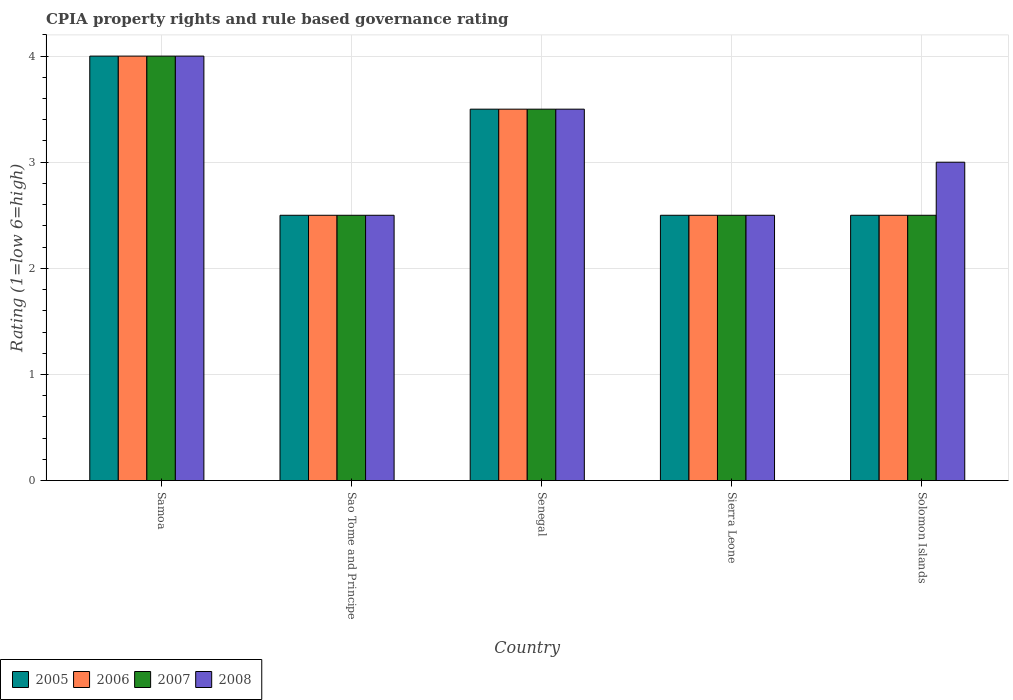How many different coloured bars are there?
Make the answer very short. 4. How many groups of bars are there?
Your answer should be compact. 5. Are the number of bars on each tick of the X-axis equal?
Make the answer very short. Yes. How many bars are there on the 2nd tick from the right?
Provide a succinct answer. 4. What is the label of the 1st group of bars from the left?
Provide a short and direct response. Samoa. What is the CPIA rating in 2005 in Solomon Islands?
Offer a very short reply. 2.5. Across all countries, what is the minimum CPIA rating in 2005?
Make the answer very short. 2.5. In which country was the CPIA rating in 2005 maximum?
Provide a short and direct response. Samoa. In which country was the CPIA rating in 2005 minimum?
Make the answer very short. Sao Tome and Principe. What is the total CPIA rating in 2006 in the graph?
Make the answer very short. 15. What is the difference between the CPIA rating in 2005 in Solomon Islands and the CPIA rating in 2007 in Senegal?
Provide a succinct answer. -1. What is the difference between the CPIA rating of/in 2006 and CPIA rating of/in 2005 in Solomon Islands?
Offer a terse response. 0. In how many countries, is the CPIA rating in 2007 greater than 3?
Offer a terse response. 2. Is the CPIA rating in 2008 in Samoa less than that in Senegal?
Make the answer very short. No. What is the difference between the highest and the second highest CPIA rating in 2006?
Give a very brief answer. -1. In how many countries, is the CPIA rating in 2006 greater than the average CPIA rating in 2006 taken over all countries?
Provide a succinct answer. 2. Is the sum of the CPIA rating in 2008 in Samoa and Sao Tome and Principe greater than the maximum CPIA rating in 2006 across all countries?
Your answer should be compact. Yes. What does the 3rd bar from the left in Sierra Leone represents?
Keep it short and to the point. 2007. Is it the case that in every country, the sum of the CPIA rating in 2005 and CPIA rating in 2008 is greater than the CPIA rating in 2006?
Provide a short and direct response. Yes. Are all the bars in the graph horizontal?
Your answer should be compact. No. Does the graph contain any zero values?
Make the answer very short. No. Does the graph contain grids?
Make the answer very short. Yes. What is the title of the graph?
Offer a terse response. CPIA property rights and rule based governance rating. Does "1985" appear as one of the legend labels in the graph?
Offer a very short reply. No. What is the Rating (1=low 6=high) of 2005 in Samoa?
Your answer should be compact. 4. What is the Rating (1=low 6=high) in 2006 in Samoa?
Keep it short and to the point. 4. What is the Rating (1=low 6=high) of 2007 in Samoa?
Provide a succinct answer. 4. What is the Rating (1=low 6=high) in 2008 in Samoa?
Make the answer very short. 4. What is the Rating (1=low 6=high) of 2006 in Sao Tome and Principe?
Offer a terse response. 2.5. What is the Rating (1=low 6=high) of 2005 in Senegal?
Offer a terse response. 3.5. What is the Rating (1=low 6=high) of 2008 in Senegal?
Provide a short and direct response. 3.5. What is the Rating (1=low 6=high) in 2005 in Sierra Leone?
Your response must be concise. 2.5. What is the Rating (1=low 6=high) of 2007 in Sierra Leone?
Offer a very short reply. 2.5. Across all countries, what is the maximum Rating (1=low 6=high) of 2005?
Offer a very short reply. 4. Across all countries, what is the maximum Rating (1=low 6=high) in 2006?
Your response must be concise. 4. Across all countries, what is the minimum Rating (1=low 6=high) of 2005?
Provide a short and direct response. 2.5. Across all countries, what is the minimum Rating (1=low 6=high) of 2006?
Provide a succinct answer. 2.5. Across all countries, what is the minimum Rating (1=low 6=high) in 2007?
Give a very brief answer. 2.5. Across all countries, what is the minimum Rating (1=low 6=high) of 2008?
Give a very brief answer. 2.5. What is the total Rating (1=low 6=high) in 2006 in the graph?
Ensure brevity in your answer.  15. What is the total Rating (1=low 6=high) of 2007 in the graph?
Make the answer very short. 15. What is the total Rating (1=low 6=high) in 2008 in the graph?
Ensure brevity in your answer.  15.5. What is the difference between the Rating (1=low 6=high) of 2006 in Samoa and that in Sao Tome and Principe?
Offer a terse response. 1.5. What is the difference between the Rating (1=low 6=high) in 2007 in Samoa and that in Sao Tome and Principe?
Ensure brevity in your answer.  1.5. What is the difference between the Rating (1=low 6=high) in 2005 in Samoa and that in Sierra Leone?
Provide a short and direct response. 1.5. What is the difference between the Rating (1=low 6=high) of 2006 in Samoa and that in Sierra Leone?
Provide a succinct answer. 1.5. What is the difference between the Rating (1=low 6=high) of 2007 in Samoa and that in Sierra Leone?
Keep it short and to the point. 1.5. What is the difference between the Rating (1=low 6=high) in 2008 in Samoa and that in Sierra Leone?
Offer a very short reply. 1.5. What is the difference between the Rating (1=low 6=high) in 2005 in Samoa and that in Solomon Islands?
Provide a succinct answer. 1.5. What is the difference between the Rating (1=low 6=high) in 2006 in Samoa and that in Solomon Islands?
Ensure brevity in your answer.  1.5. What is the difference between the Rating (1=low 6=high) of 2007 in Samoa and that in Solomon Islands?
Ensure brevity in your answer.  1.5. What is the difference between the Rating (1=low 6=high) of 2008 in Samoa and that in Solomon Islands?
Offer a terse response. 1. What is the difference between the Rating (1=low 6=high) of 2005 in Sao Tome and Principe and that in Senegal?
Give a very brief answer. -1. What is the difference between the Rating (1=low 6=high) of 2007 in Sao Tome and Principe and that in Senegal?
Your answer should be very brief. -1. What is the difference between the Rating (1=low 6=high) of 2008 in Sao Tome and Principe and that in Senegal?
Make the answer very short. -1. What is the difference between the Rating (1=low 6=high) of 2005 in Sao Tome and Principe and that in Sierra Leone?
Provide a short and direct response. 0. What is the difference between the Rating (1=low 6=high) of 2006 in Sao Tome and Principe and that in Sierra Leone?
Keep it short and to the point. 0. What is the difference between the Rating (1=low 6=high) of 2006 in Sao Tome and Principe and that in Solomon Islands?
Your answer should be very brief. 0. What is the difference between the Rating (1=low 6=high) of 2007 in Sao Tome and Principe and that in Solomon Islands?
Your response must be concise. 0. What is the difference between the Rating (1=low 6=high) of 2005 in Senegal and that in Solomon Islands?
Give a very brief answer. 1. What is the difference between the Rating (1=low 6=high) of 2007 in Senegal and that in Solomon Islands?
Your answer should be very brief. 1. What is the difference between the Rating (1=low 6=high) of 2005 in Sierra Leone and that in Solomon Islands?
Make the answer very short. 0. What is the difference between the Rating (1=low 6=high) of 2006 in Sierra Leone and that in Solomon Islands?
Offer a terse response. 0. What is the difference between the Rating (1=low 6=high) in 2007 in Sierra Leone and that in Solomon Islands?
Your answer should be very brief. 0. What is the difference between the Rating (1=low 6=high) of 2005 in Samoa and the Rating (1=low 6=high) of 2008 in Sao Tome and Principe?
Your response must be concise. 1.5. What is the difference between the Rating (1=low 6=high) in 2006 in Samoa and the Rating (1=low 6=high) in 2007 in Sao Tome and Principe?
Your response must be concise. 1.5. What is the difference between the Rating (1=low 6=high) in 2007 in Samoa and the Rating (1=low 6=high) in 2008 in Sao Tome and Principe?
Offer a terse response. 1.5. What is the difference between the Rating (1=low 6=high) of 2005 in Samoa and the Rating (1=low 6=high) of 2006 in Senegal?
Ensure brevity in your answer.  0.5. What is the difference between the Rating (1=low 6=high) of 2005 in Samoa and the Rating (1=low 6=high) of 2008 in Senegal?
Offer a terse response. 0.5. What is the difference between the Rating (1=low 6=high) in 2005 in Samoa and the Rating (1=low 6=high) in 2006 in Sierra Leone?
Your answer should be compact. 1.5. What is the difference between the Rating (1=low 6=high) in 2005 in Samoa and the Rating (1=low 6=high) in 2007 in Sierra Leone?
Your answer should be very brief. 1.5. What is the difference between the Rating (1=low 6=high) in 2006 in Samoa and the Rating (1=low 6=high) in 2007 in Sierra Leone?
Your answer should be compact. 1.5. What is the difference between the Rating (1=low 6=high) in 2007 in Samoa and the Rating (1=low 6=high) in 2008 in Sierra Leone?
Provide a succinct answer. 1.5. What is the difference between the Rating (1=low 6=high) in 2005 in Samoa and the Rating (1=low 6=high) in 2006 in Solomon Islands?
Keep it short and to the point. 1.5. What is the difference between the Rating (1=low 6=high) of 2006 in Samoa and the Rating (1=low 6=high) of 2007 in Solomon Islands?
Offer a very short reply. 1.5. What is the difference between the Rating (1=low 6=high) in 2006 in Samoa and the Rating (1=low 6=high) in 2008 in Solomon Islands?
Provide a short and direct response. 1. What is the difference between the Rating (1=low 6=high) of 2005 in Sao Tome and Principe and the Rating (1=low 6=high) of 2007 in Senegal?
Keep it short and to the point. -1. What is the difference between the Rating (1=low 6=high) in 2006 in Sao Tome and Principe and the Rating (1=low 6=high) in 2007 in Senegal?
Provide a short and direct response. -1. What is the difference between the Rating (1=low 6=high) of 2007 in Sao Tome and Principe and the Rating (1=low 6=high) of 2008 in Senegal?
Your answer should be compact. -1. What is the difference between the Rating (1=low 6=high) of 2005 in Sao Tome and Principe and the Rating (1=low 6=high) of 2007 in Sierra Leone?
Provide a short and direct response. 0. What is the difference between the Rating (1=low 6=high) in 2005 in Sao Tome and Principe and the Rating (1=low 6=high) in 2008 in Sierra Leone?
Give a very brief answer. 0. What is the difference between the Rating (1=low 6=high) in 2006 in Sao Tome and Principe and the Rating (1=low 6=high) in 2007 in Sierra Leone?
Provide a succinct answer. 0. What is the difference between the Rating (1=low 6=high) of 2006 in Sao Tome and Principe and the Rating (1=low 6=high) of 2008 in Sierra Leone?
Offer a terse response. 0. What is the difference between the Rating (1=low 6=high) in 2005 in Sao Tome and Principe and the Rating (1=low 6=high) in 2007 in Solomon Islands?
Your response must be concise. 0. What is the difference between the Rating (1=low 6=high) in 2006 in Sao Tome and Principe and the Rating (1=low 6=high) in 2007 in Solomon Islands?
Offer a very short reply. 0. What is the difference between the Rating (1=low 6=high) in 2006 in Sao Tome and Principe and the Rating (1=low 6=high) in 2008 in Solomon Islands?
Provide a succinct answer. -0.5. What is the difference between the Rating (1=low 6=high) of 2007 in Sao Tome and Principe and the Rating (1=low 6=high) of 2008 in Solomon Islands?
Keep it short and to the point. -0.5. What is the difference between the Rating (1=low 6=high) in 2005 in Senegal and the Rating (1=low 6=high) in 2006 in Sierra Leone?
Offer a very short reply. 1. What is the difference between the Rating (1=low 6=high) in 2005 in Senegal and the Rating (1=low 6=high) in 2008 in Sierra Leone?
Your answer should be very brief. 1. What is the difference between the Rating (1=low 6=high) of 2006 in Senegal and the Rating (1=low 6=high) of 2007 in Sierra Leone?
Provide a short and direct response. 1. What is the difference between the Rating (1=low 6=high) of 2006 in Senegal and the Rating (1=low 6=high) of 2008 in Sierra Leone?
Keep it short and to the point. 1. What is the difference between the Rating (1=low 6=high) of 2007 in Senegal and the Rating (1=low 6=high) of 2008 in Sierra Leone?
Keep it short and to the point. 1. What is the difference between the Rating (1=low 6=high) of 2005 in Senegal and the Rating (1=low 6=high) of 2008 in Solomon Islands?
Offer a terse response. 0.5. What is the difference between the Rating (1=low 6=high) of 2006 in Senegal and the Rating (1=low 6=high) of 2008 in Solomon Islands?
Your answer should be compact. 0.5. What is the difference between the Rating (1=low 6=high) in 2007 in Senegal and the Rating (1=low 6=high) in 2008 in Solomon Islands?
Offer a very short reply. 0.5. What is the difference between the Rating (1=low 6=high) of 2005 in Sierra Leone and the Rating (1=low 6=high) of 2006 in Solomon Islands?
Your response must be concise. 0. What is the difference between the Rating (1=low 6=high) in 2005 in Sierra Leone and the Rating (1=low 6=high) in 2007 in Solomon Islands?
Your answer should be very brief. 0. What is the difference between the Rating (1=low 6=high) in 2005 in Sierra Leone and the Rating (1=low 6=high) in 2008 in Solomon Islands?
Your answer should be very brief. -0.5. What is the difference between the Rating (1=low 6=high) in 2007 and Rating (1=low 6=high) in 2008 in Samoa?
Provide a short and direct response. 0. What is the difference between the Rating (1=low 6=high) of 2005 and Rating (1=low 6=high) of 2006 in Sao Tome and Principe?
Offer a terse response. 0. What is the difference between the Rating (1=low 6=high) in 2005 and Rating (1=low 6=high) in 2007 in Sao Tome and Principe?
Make the answer very short. 0. What is the difference between the Rating (1=low 6=high) in 2005 and Rating (1=low 6=high) in 2008 in Sao Tome and Principe?
Your response must be concise. 0. What is the difference between the Rating (1=low 6=high) of 2006 and Rating (1=low 6=high) of 2007 in Sao Tome and Principe?
Offer a very short reply. 0. What is the difference between the Rating (1=low 6=high) in 2006 and Rating (1=low 6=high) in 2008 in Sao Tome and Principe?
Your answer should be compact. 0. What is the difference between the Rating (1=low 6=high) of 2007 and Rating (1=low 6=high) of 2008 in Sao Tome and Principe?
Your answer should be very brief. 0. What is the difference between the Rating (1=low 6=high) of 2005 and Rating (1=low 6=high) of 2006 in Senegal?
Your answer should be compact. 0. What is the difference between the Rating (1=low 6=high) in 2006 and Rating (1=low 6=high) in 2008 in Senegal?
Provide a succinct answer. 0. What is the difference between the Rating (1=low 6=high) of 2005 and Rating (1=low 6=high) of 2006 in Sierra Leone?
Keep it short and to the point. 0. What is the difference between the Rating (1=low 6=high) of 2005 and Rating (1=low 6=high) of 2007 in Sierra Leone?
Your answer should be compact. 0. What is the difference between the Rating (1=low 6=high) of 2006 and Rating (1=low 6=high) of 2008 in Sierra Leone?
Make the answer very short. 0. What is the difference between the Rating (1=low 6=high) of 2005 and Rating (1=low 6=high) of 2006 in Solomon Islands?
Make the answer very short. 0. What is the difference between the Rating (1=low 6=high) of 2005 and Rating (1=low 6=high) of 2007 in Solomon Islands?
Offer a very short reply. 0. What is the difference between the Rating (1=low 6=high) of 2005 and Rating (1=low 6=high) of 2008 in Solomon Islands?
Your answer should be compact. -0.5. What is the difference between the Rating (1=low 6=high) of 2006 and Rating (1=low 6=high) of 2007 in Solomon Islands?
Offer a terse response. 0. What is the difference between the Rating (1=low 6=high) in 2007 and Rating (1=low 6=high) in 2008 in Solomon Islands?
Your answer should be very brief. -0.5. What is the ratio of the Rating (1=low 6=high) of 2008 in Samoa to that in Sao Tome and Principe?
Offer a very short reply. 1.6. What is the ratio of the Rating (1=low 6=high) in 2006 in Samoa to that in Sierra Leone?
Your response must be concise. 1.6. What is the ratio of the Rating (1=low 6=high) in 2007 in Samoa to that in Sierra Leone?
Your answer should be very brief. 1.6. What is the ratio of the Rating (1=low 6=high) in 2008 in Samoa to that in Sierra Leone?
Offer a very short reply. 1.6. What is the ratio of the Rating (1=low 6=high) in 2005 in Samoa to that in Solomon Islands?
Offer a very short reply. 1.6. What is the ratio of the Rating (1=low 6=high) in 2006 in Samoa to that in Solomon Islands?
Give a very brief answer. 1.6. What is the ratio of the Rating (1=low 6=high) of 2007 in Samoa to that in Solomon Islands?
Your answer should be compact. 1.6. What is the ratio of the Rating (1=low 6=high) of 2005 in Sao Tome and Principe to that in Senegal?
Provide a short and direct response. 0.71. What is the ratio of the Rating (1=low 6=high) of 2006 in Sao Tome and Principe to that in Senegal?
Provide a succinct answer. 0.71. What is the ratio of the Rating (1=low 6=high) in 2005 in Sao Tome and Principe to that in Sierra Leone?
Keep it short and to the point. 1. What is the ratio of the Rating (1=low 6=high) of 2005 in Sao Tome and Principe to that in Solomon Islands?
Offer a terse response. 1. What is the ratio of the Rating (1=low 6=high) in 2007 in Sao Tome and Principe to that in Solomon Islands?
Ensure brevity in your answer.  1. What is the ratio of the Rating (1=low 6=high) of 2008 in Sao Tome and Principe to that in Solomon Islands?
Provide a succinct answer. 0.83. What is the ratio of the Rating (1=low 6=high) of 2005 in Senegal to that in Sierra Leone?
Make the answer very short. 1.4. What is the ratio of the Rating (1=low 6=high) in 2005 in Senegal to that in Solomon Islands?
Make the answer very short. 1.4. What is the ratio of the Rating (1=low 6=high) of 2007 in Senegal to that in Solomon Islands?
Provide a short and direct response. 1.4. What is the ratio of the Rating (1=low 6=high) in 2008 in Sierra Leone to that in Solomon Islands?
Ensure brevity in your answer.  0.83. What is the difference between the highest and the second highest Rating (1=low 6=high) in 2006?
Offer a very short reply. 0.5. What is the difference between the highest and the lowest Rating (1=low 6=high) of 2008?
Your answer should be compact. 1.5. 